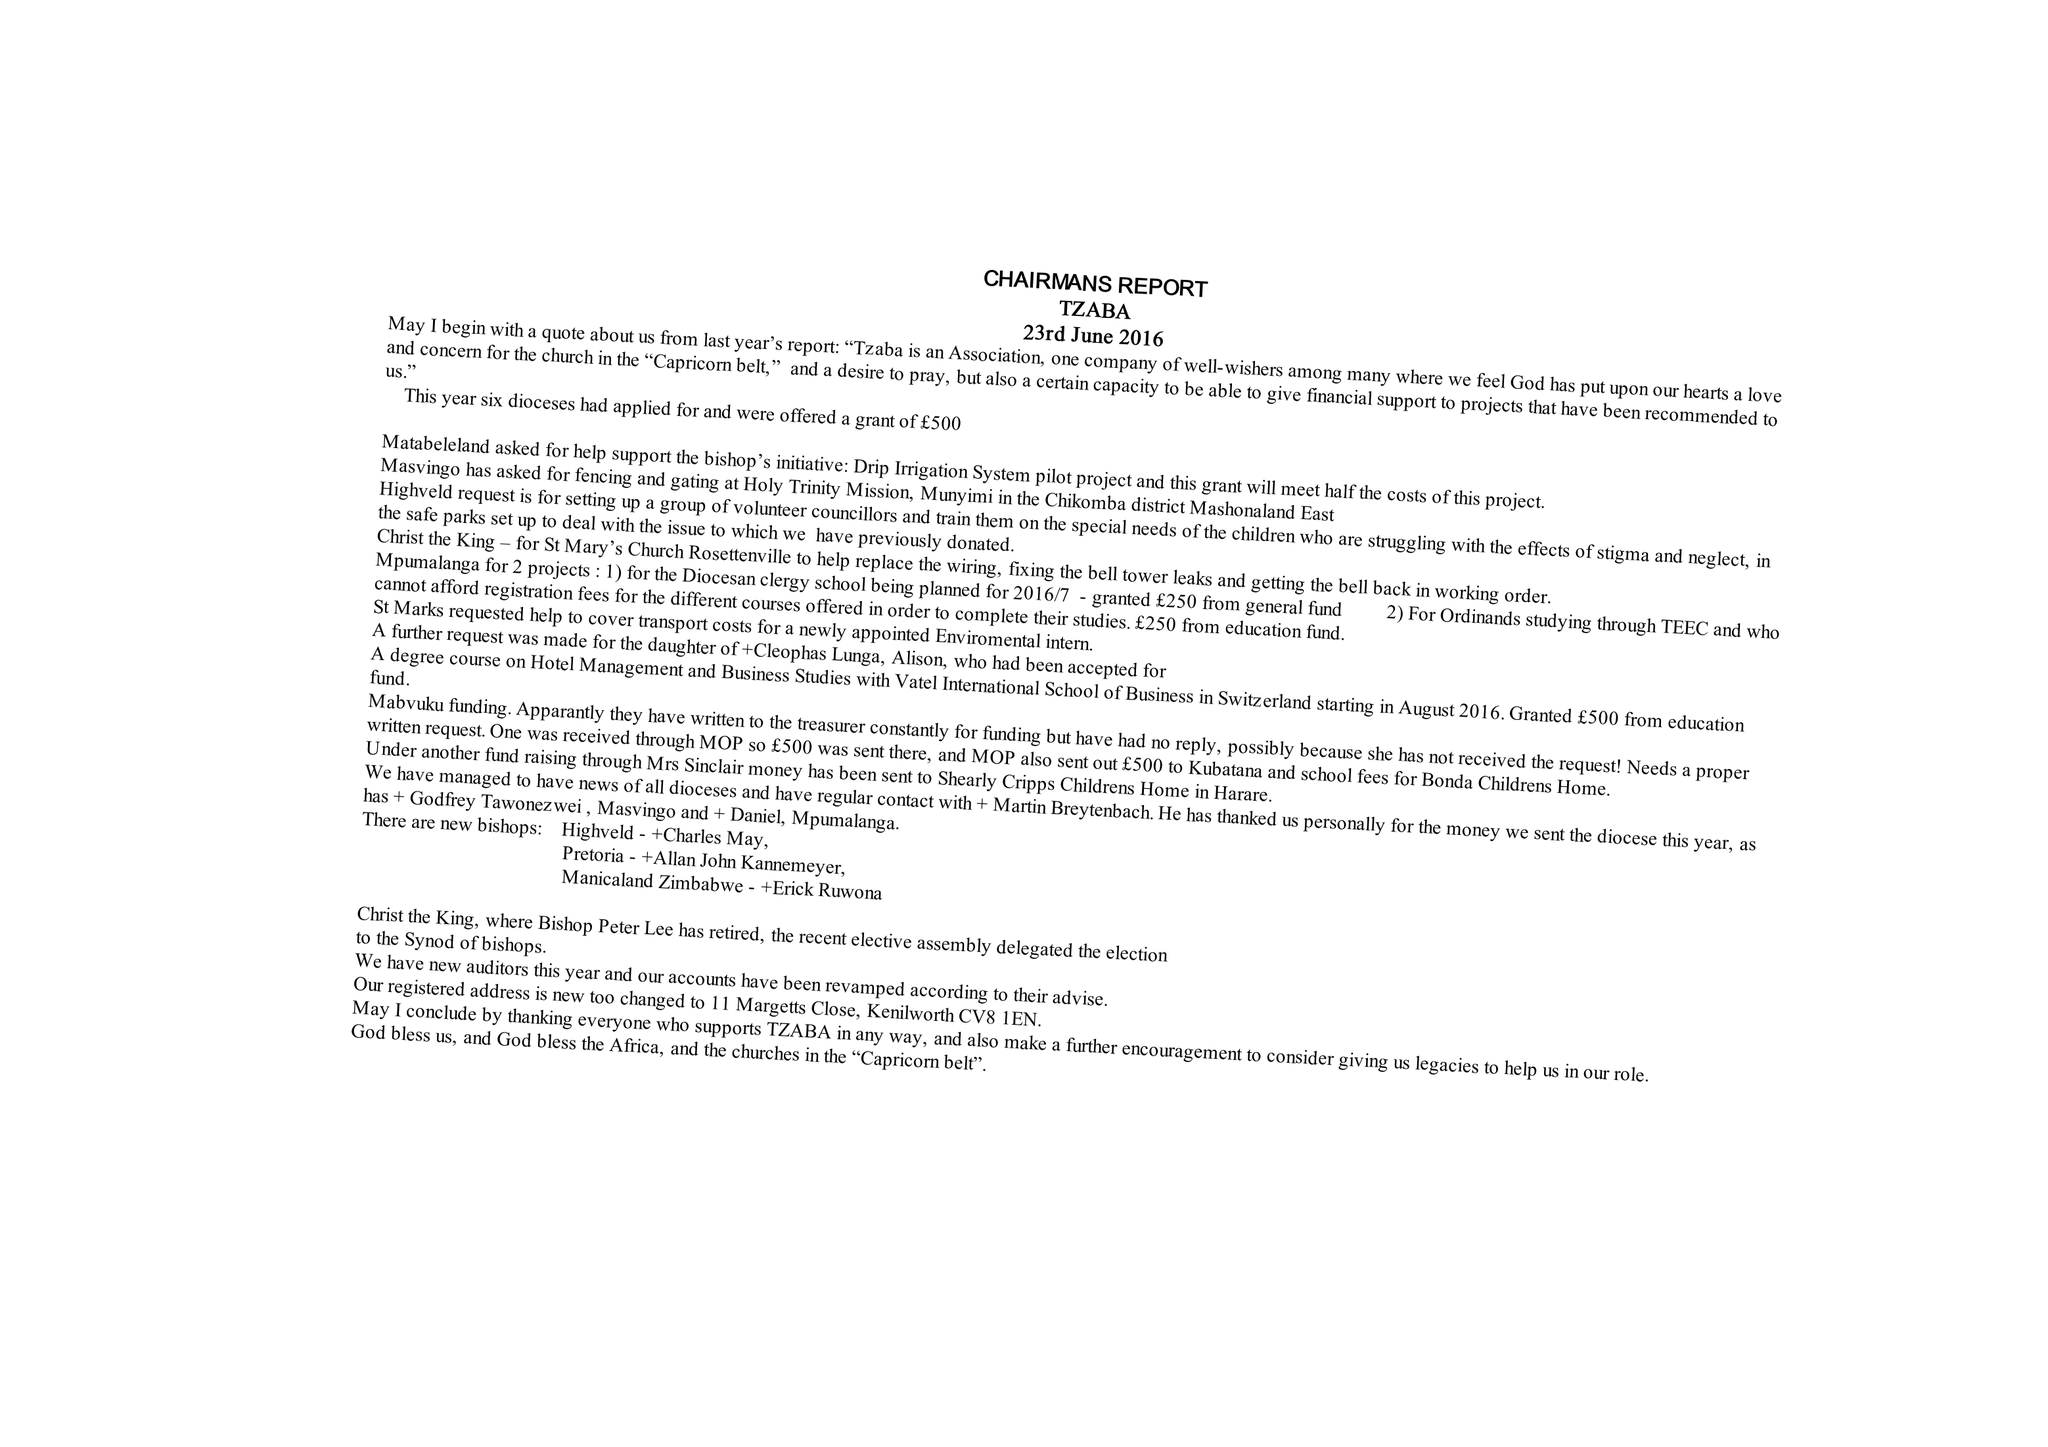What is the value for the charity_number?
Answer the question using a single word or phrase. 238146 